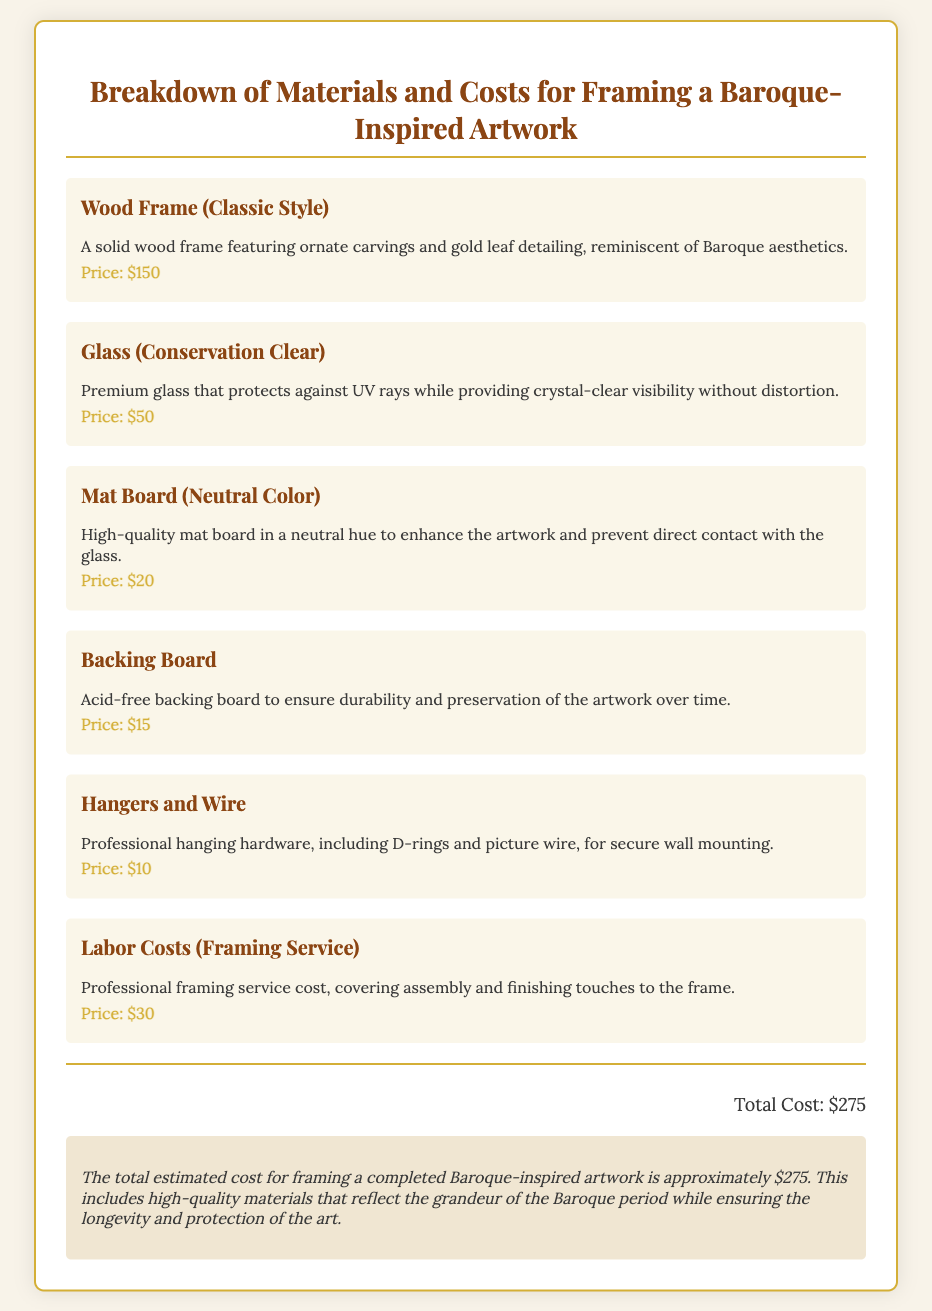what are the materials included in the framing costs? The document lists several materials for framing the artwork, including a wood frame, glass, mat board, backing board, hangers and wire, and labor costs.
Answer: Wood Frame, Glass, Mat Board, Backing Board, Hangers and Wire, Labor Costs what is the price of the wood frame? The price listed for the wood frame is specified in the document.
Answer: $150 how much does the labor cost for framing services? The document provides the specific cost for labor associated with the framing service.
Answer: $30 what is the total estimated cost for framing? The total cost for framing the artwork is summarized at the end of the document.
Answer: $275 what type of glass is used for the framing? The document specifies the type of glass used in the framing process.
Answer: Conservation Clear how does the mat board enhance the artwork? The mat board is described in the document as enhancing the artwork while protecting it from direct contact with the glass.
Answer: High-quality mat board in a neutral hue what can be found on the backing board? The backing board is described in the document, specifically regarding its function related to the artwork.
Answer: Acid-free backing board why is the wood frame characterized as classic? The document provides a description highlighting the style of the wood frame.
Answer: Featuring ornate carvings and gold leaf detailing how is the total cost calculated? The total cost is derived from adding up all individual material and labor costs listed in the document.
Answer: Sum of all material and labor costs 